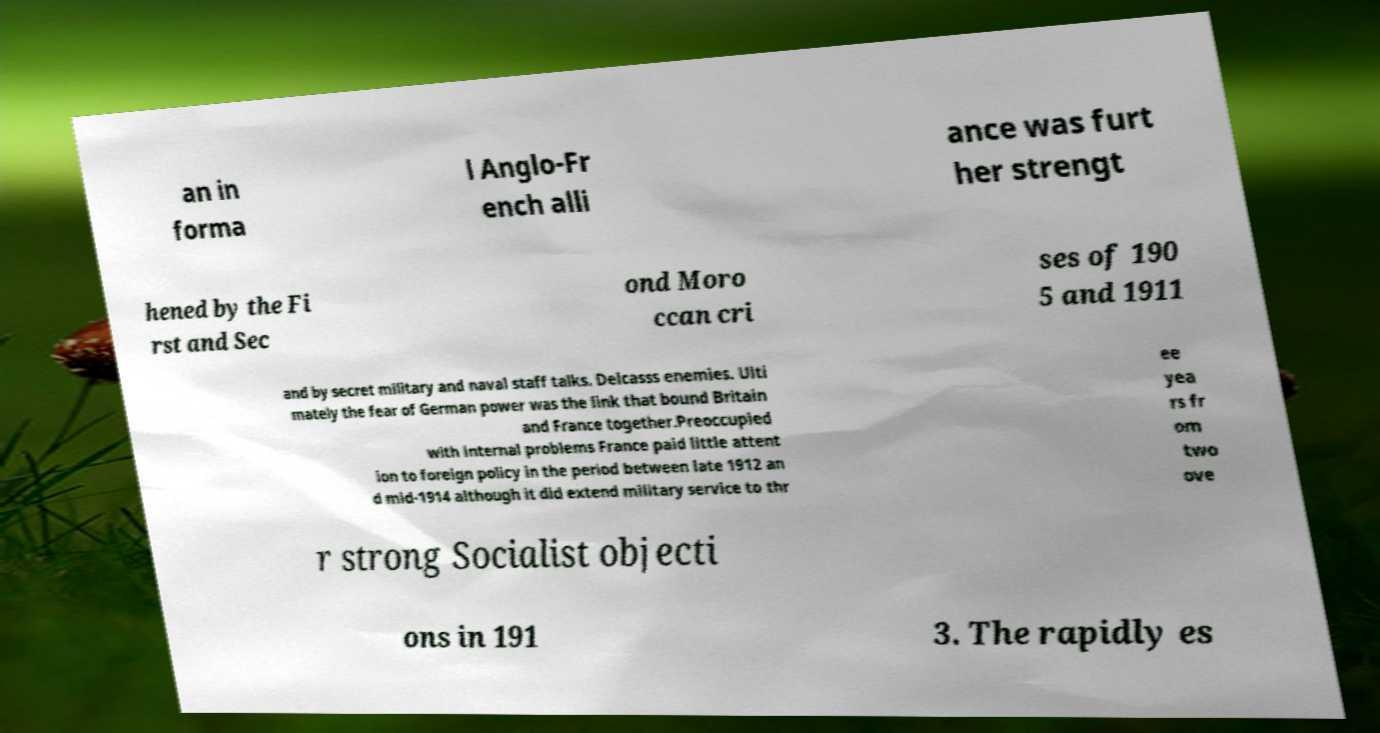Please read and relay the text visible in this image. What does it say? an in forma l Anglo-Fr ench alli ance was furt her strengt hened by the Fi rst and Sec ond Moro ccan cri ses of 190 5 and 1911 and by secret military and naval staff talks. Delcasss enemies. Ulti mately the fear of German power was the link that bound Britain and France together.Preoccupied with internal problems France paid little attent ion to foreign policy in the period between late 1912 an d mid-1914 although it did extend military service to thr ee yea rs fr om two ove r strong Socialist objecti ons in 191 3. The rapidly es 